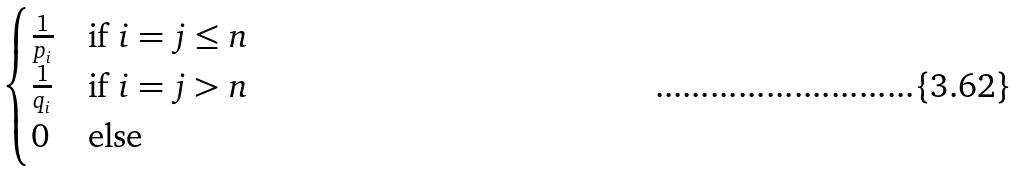Convert formula to latex. <formula><loc_0><loc_0><loc_500><loc_500>\begin{cases} \frac { 1 } { p _ { i } } & \text {if $i = j \leq n$ } \\ \frac { 1 } { q _ { i } } & \text {if $i = j > n$ } \\ 0 & \text {else} \end{cases}</formula> 